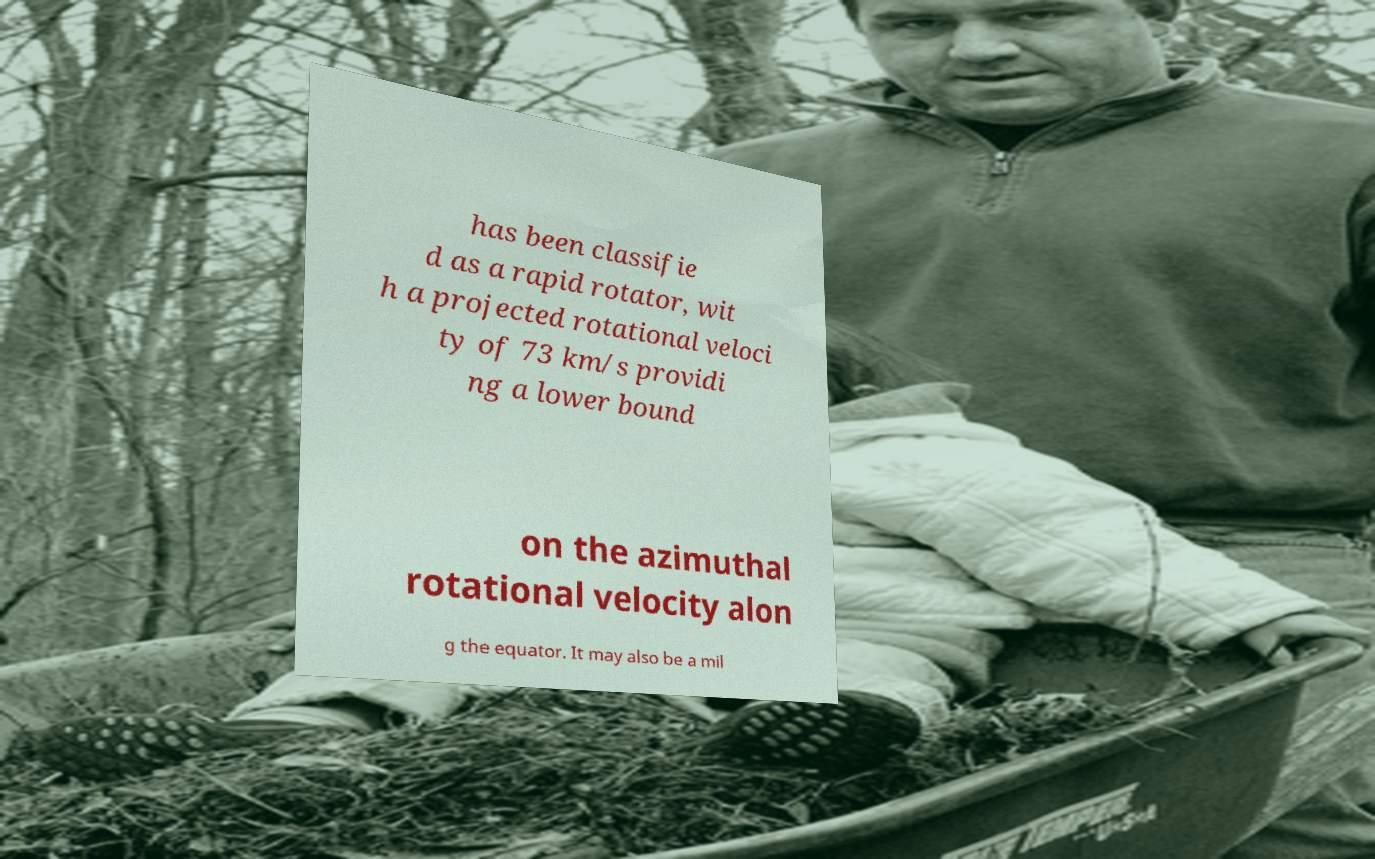There's text embedded in this image that I need extracted. Can you transcribe it verbatim? has been classifie d as a rapid rotator, wit h a projected rotational veloci ty of 73 km/s providi ng a lower bound on the azimuthal rotational velocity alon g the equator. It may also be a mil 